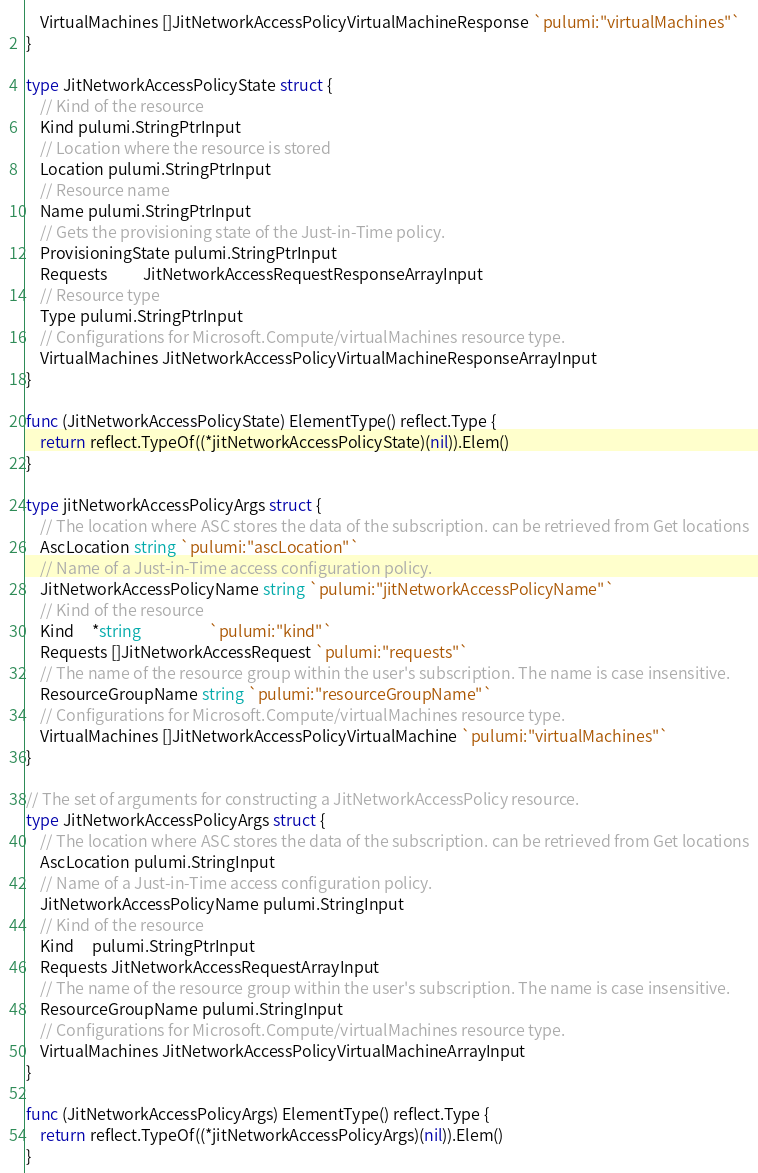<code> <loc_0><loc_0><loc_500><loc_500><_Go_>	VirtualMachines []JitNetworkAccessPolicyVirtualMachineResponse `pulumi:"virtualMachines"`
}

type JitNetworkAccessPolicyState struct {
	// Kind of the resource
	Kind pulumi.StringPtrInput
	// Location where the resource is stored
	Location pulumi.StringPtrInput
	// Resource name
	Name pulumi.StringPtrInput
	// Gets the provisioning state of the Just-in-Time policy.
	ProvisioningState pulumi.StringPtrInput
	Requests          JitNetworkAccessRequestResponseArrayInput
	// Resource type
	Type pulumi.StringPtrInput
	// Configurations for Microsoft.Compute/virtualMachines resource type.
	VirtualMachines JitNetworkAccessPolicyVirtualMachineResponseArrayInput
}

func (JitNetworkAccessPolicyState) ElementType() reflect.Type {
	return reflect.TypeOf((*jitNetworkAccessPolicyState)(nil)).Elem()
}

type jitNetworkAccessPolicyArgs struct {
	// The location where ASC stores the data of the subscription. can be retrieved from Get locations
	AscLocation string `pulumi:"ascLocation"`
	// Name of a Just-in-Time access configuration policy.
	JitNetworkAccessPolicyName string `pulumi:"jitNetworkAccessPolicyName"`
	// Kind of the resource
	Kind     *string                   `pulumi:"kind"`
	Requests []JitNetworkAccessRequest `pulumi:"requests"`
	// The name of the resource group within the user's subscription. The name is case insensitive.
	ResourceGroupName string `pulumi:"resourceGroupName"`
	// Configurations for Microsoft.Compute/virtualMachines resource type.
	VirtualMachines []JitNetworkAccessPolicyVirtualMachine `pulumi:"virtualMachines"`
}

// The set of arguments for constructing a JitNetworkAccessPolicy resource.
type JitNetworkAccessPolicyArgs struct {
	// The location where ASC stores the data of the subscription. can be retrieved from Get locations
	AscLocation pulumi.StringInput
	// Name of a Just-in-Time access configuration policy.
	JitNetworkAccessPolicyName pulumi.StringInput
	// Kind of the resource
	Kind     pulumi.StringPtrInput
	Requests JitNetworkAccessRequestArrayInput
	// The name of the resource group within the user's subscription. The name is case insensitive.
	ResourceGroupName pulumi.StringInput
	// Configurations for Microsoft.Compute/virtualMachines resource type.
	VirtualMachines JitNetworkAccessPolicyVirtualMachineArrayInput
}

func (JitNetworkAccessPolicyArgs) ElementType() reflect.Type {
	return reflect.TypeOf((*jitNetworkAccessPolicyArgs)(nil)).Elem()
}
</code> 